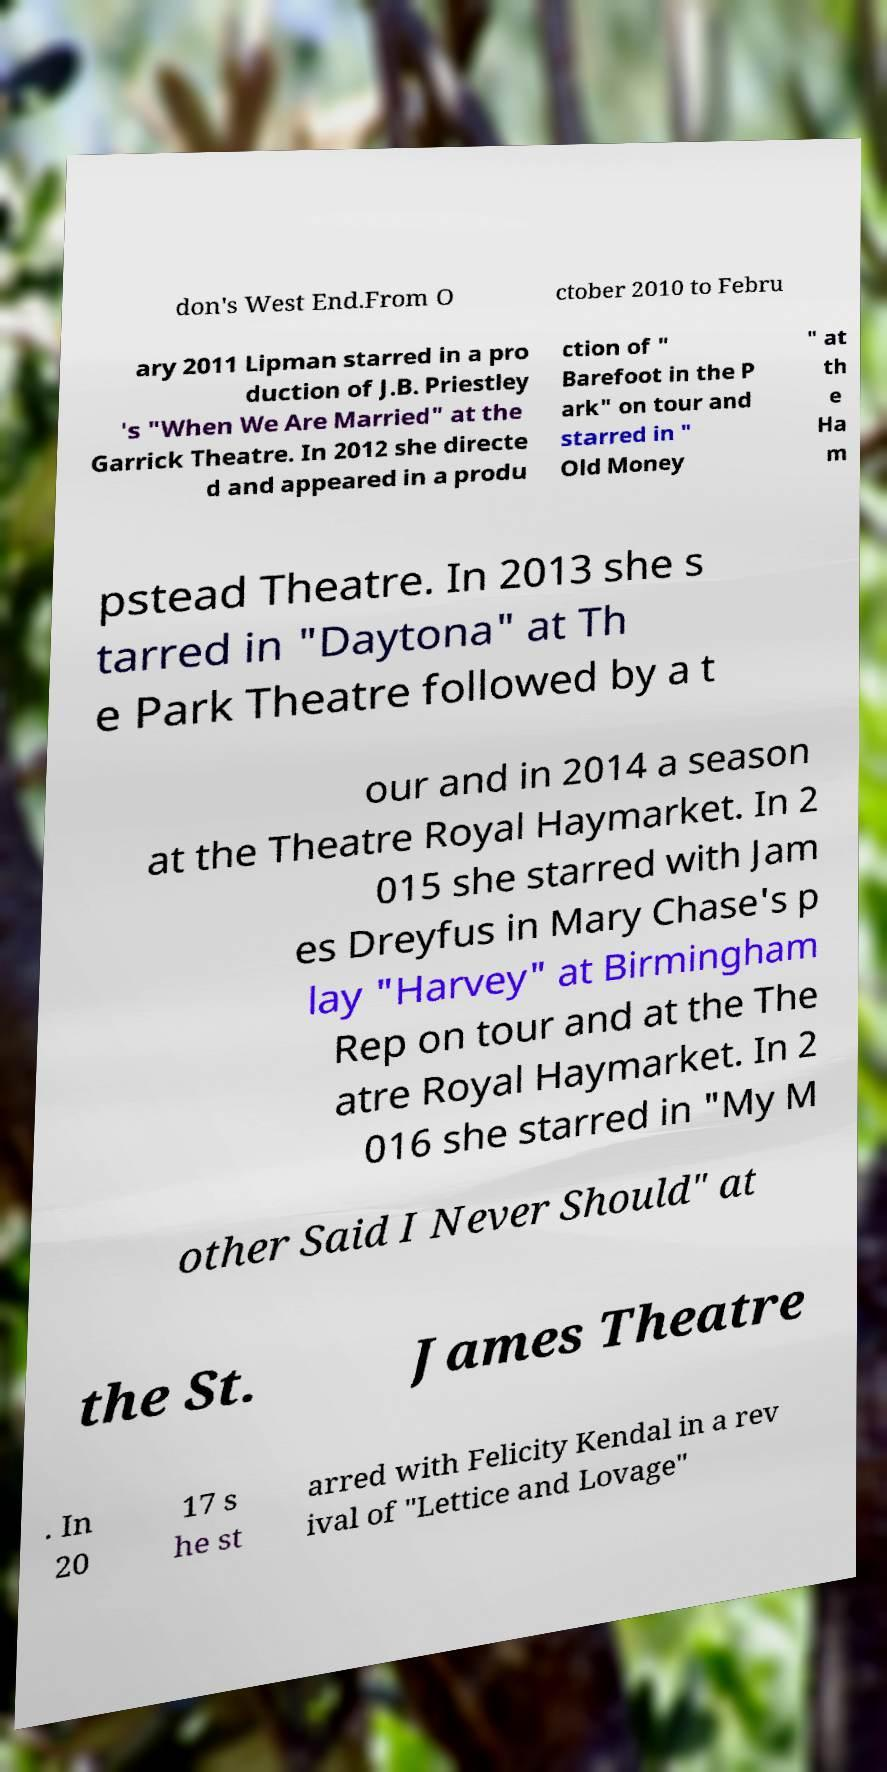Please identify and transcribe the text found in this image. don's West End.From O ctober 2010 to Febru ary 2011 Lipman starred in a pro duction of J.B. Priestley 's "When We Are Married" at the Garrick Theatre. In 2012 she directe d and appeared in a produ ction of " Barefoot in the P ark" on tour and starred in " Old Money " at th e Ha m pstead Theatre. In 2013 she s tarred in "Daytona" at Th e Park Theatre followed by a t our and in 2014 a season at the Theatre Royal Haymarket. In 2 015 she starred with Jam es Dreyfus in Mary Chase's p lay "Harvey" at Birmingham Rep on tour and at the The atre Royal Haymarket. In 2 016 she starred in "My M other Said I Never Should" at the St. James Theatre . In 20 17 s he st arred with Felicity Kendal in a rev ival of "Lettice and Lovage" 